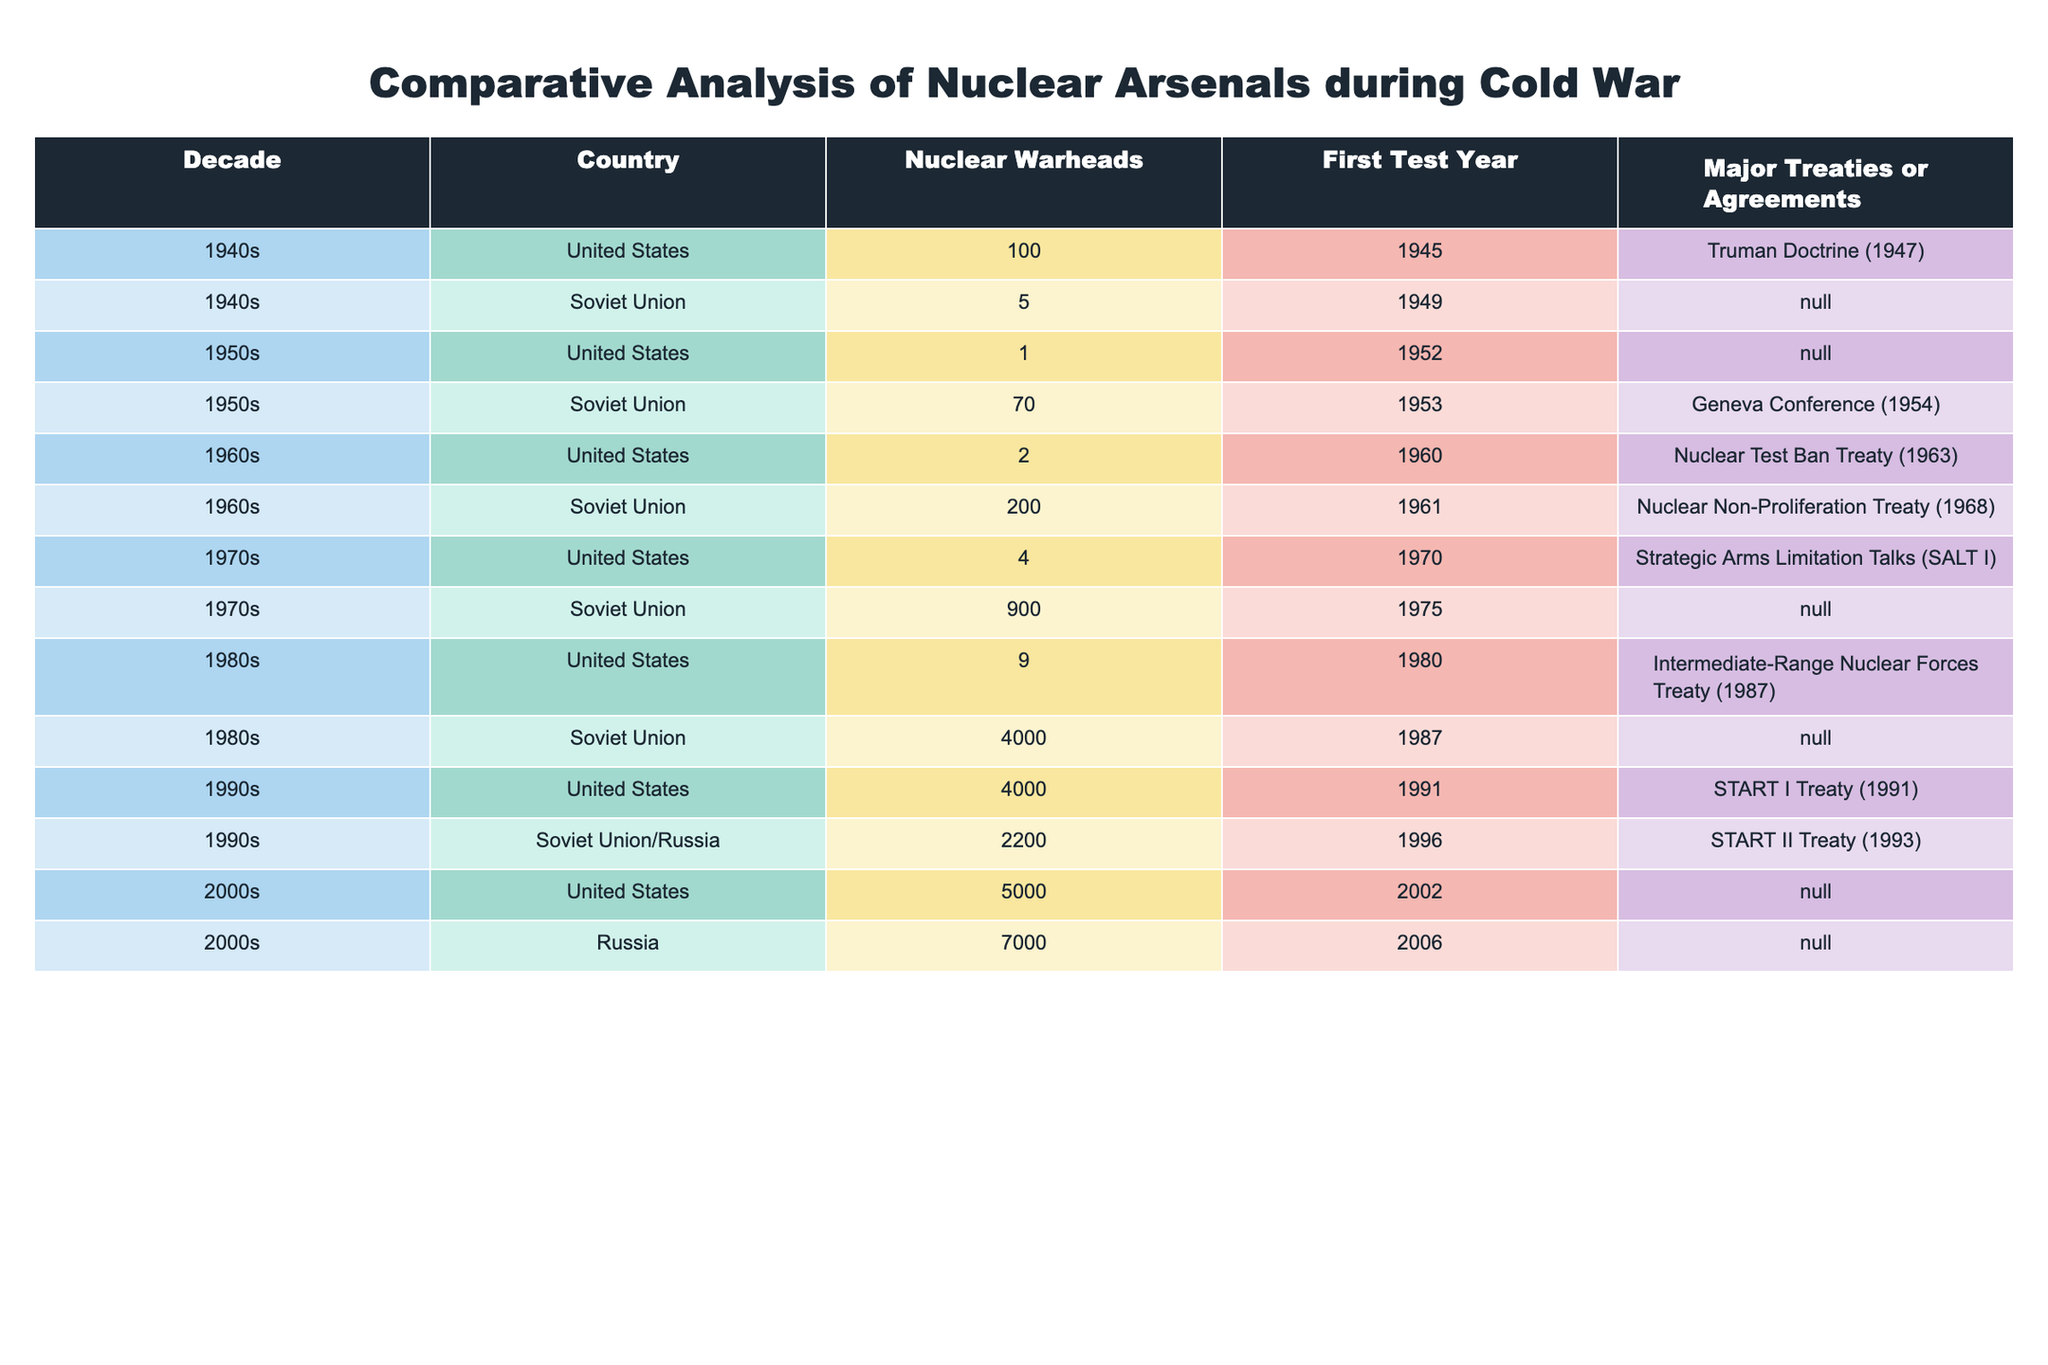What decade saw the first nuclear tests by the United States and the Soviet Union? The United States conducted its first nuclear test in 1945 during the 1940s, while the Soviet Union's first test was in 1949, also within the same decade. Thus, the decade in question is the 1940s.
Answer: 1940s How many nuclear warheads did the Soviet Union have compared to the United States in the 1980s? In the 1980s, the United States had 9 nuclear warheads, while the Soviet Union had 4000 warheads. Thus, the Soviet Union had significantly more warheads than the United States, specifically 4000 - 9 = 3991 more.
Answer: 3991 Was it true that the total number of nuclear warheads for the United States exceeded that of the Soviet Union in the 1990s? In the 1990s, the United States had 4000 nuclear warheads and the Soviet Union/Russia had 2200 warheads. Therefore, it is true that the United States’ arsenal exceeded that of the Soviet Union/Russia.
Answer: Yes What was the average number of nuclear warheads for the United States across all decades listed? The United States had the following nuclear warheads: 100 (1940s), 1 (1950s), 2 (1960s), 4 (1970s), 9 (1980s), 4000 (1990s), 5000 (2000s). To find the average, we sum these values (100 + 1 + 2 + 4 + 9 + 4000 + 5000 = 6116) and divide by 7 (the number of decades), resulting in an average of 6116 / 7 = 873.71.
Answer: 873.71 Which treaty was associated with the first nuclear tests by each country, and did both countries sign a treaty in the 1960s? The Truman Doctrine (1947) is associated with the United States' first test, while there were no treaties associated with the Soviet Union's first test in 1949. In the 1960s, the United States signed the Nuclear Test Ban Treaty (1963), and the Soviet Union signed the Nuclear Non-Proliferation Treaty (1968). Therefore, both countries did sign significant treaties in the 1960s.
Answer: Yes 